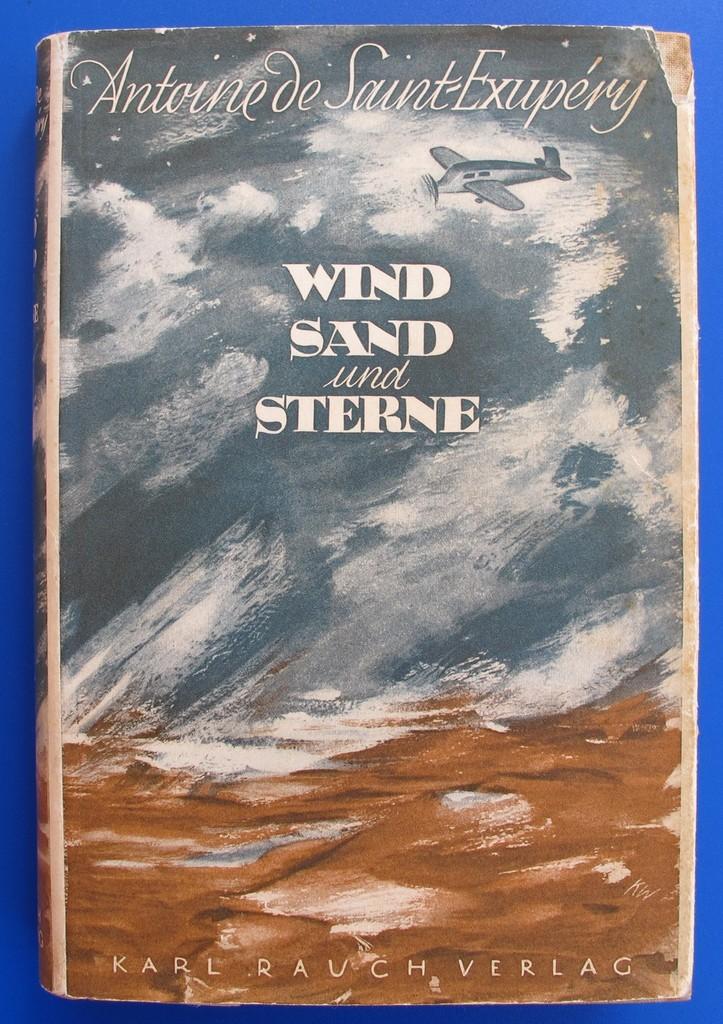Who is the author of the book?
Offer a terse response. Karl rauch verlag. 